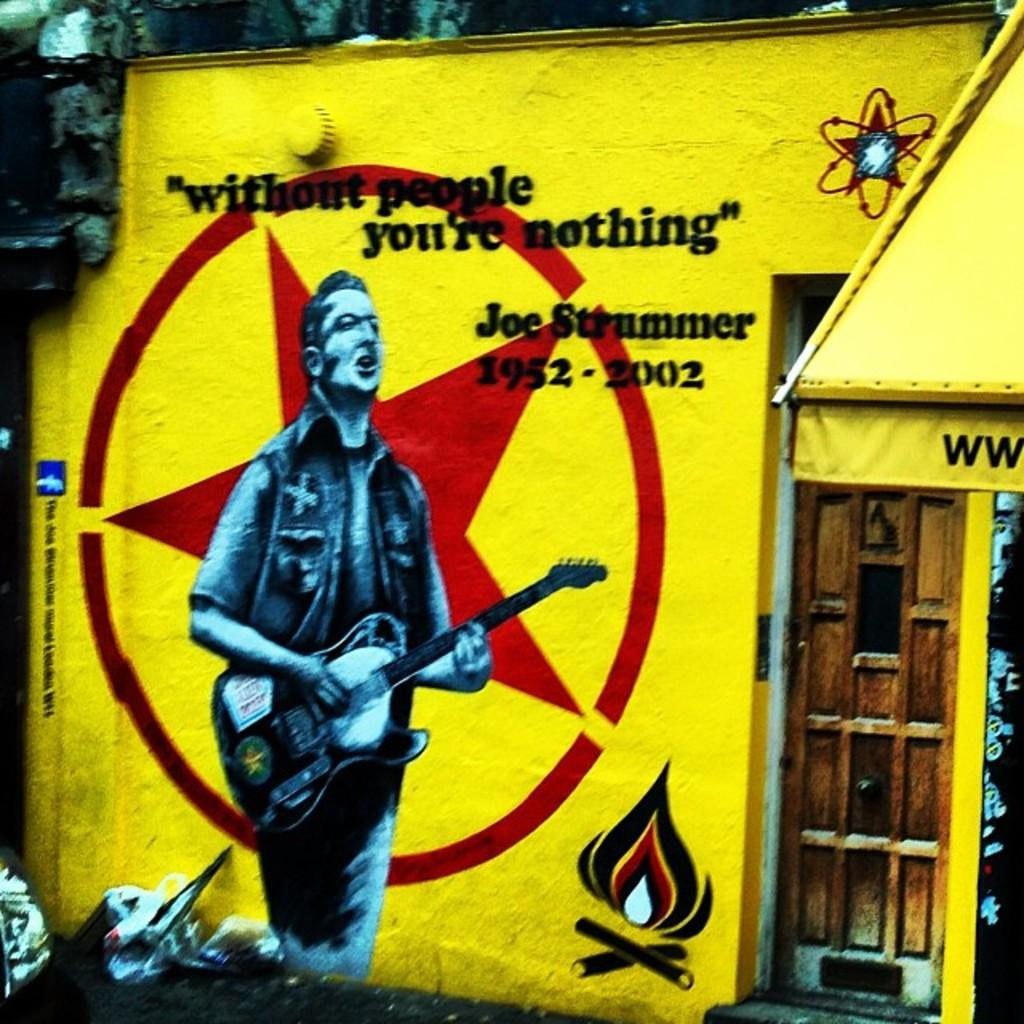<image>
Summarize the visual content of the image. A building painted bright yellow has a picture of a man playing guitar and slogan "without people you 